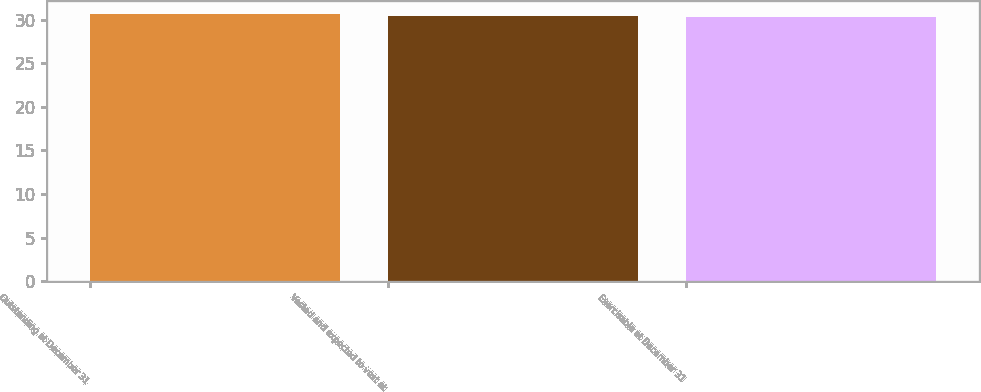<chart> <loc_0><loc_0><loc_500><loc_500><bar_chart><fcel>Outstanding at December 31<fcel>Vested and expected to vest at<fcel>Exercisable at December 31<nl><fcel>30.63<fcel>30.44<fcel>30.28<nl></chart> 